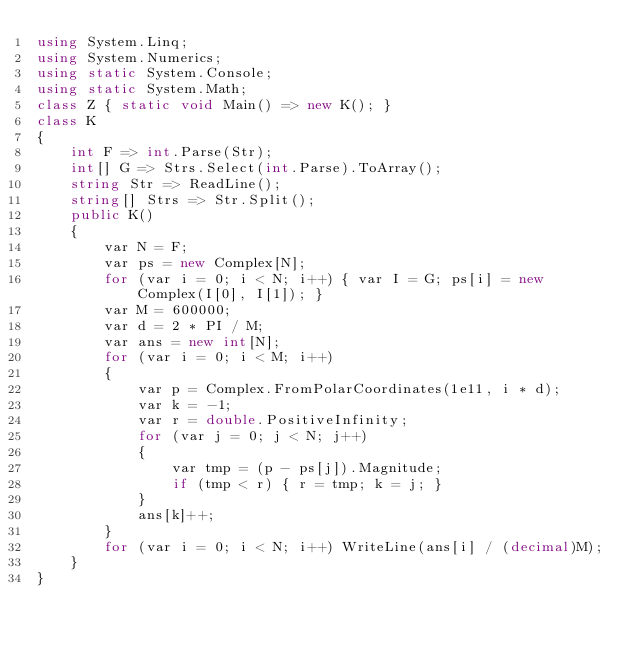<code> <loc_0><loc_0><loc_500><loc_500><_C#_>using System.Linq;
using System.Numerics;
using static System.Console;
using static System.Math;
class Z { static void Main() => new K(); }
class K
{
	int F => int.Parse(Str);
	int[] G => Strs.Select(int.Parse).ToArray();
	string Str => ReadLine();
	string[] Strs => Str.Split();
	public K()
	{
		var N = F;
		var ps = new Complex[N];
		for (var i = 0; i < N; i++) { var I = G; ps[i] = new Complex(I[0], I[1]); }
		var M = 600000;
		var d = 2 * PI / M;
		var ans = new int[N];
		for (var i = 0; i < M; i++)
		{
			var p = Complex.FromPolarCoordinates(1e11, i * d);
			var k = -1;
			var r = double.PositiveInfinity;
			for (var j = 0; j < N; j++)
			{
				var tmp = (p - ps[j]).Magnitude;
				if (tmp < r) { r = tmp; k = j; }
			}
			ans[k]++;
		}
		for (var i = 0; i < N; i++) WriteLine(ans[i] / (decimal)M);
	}
}
</code> 